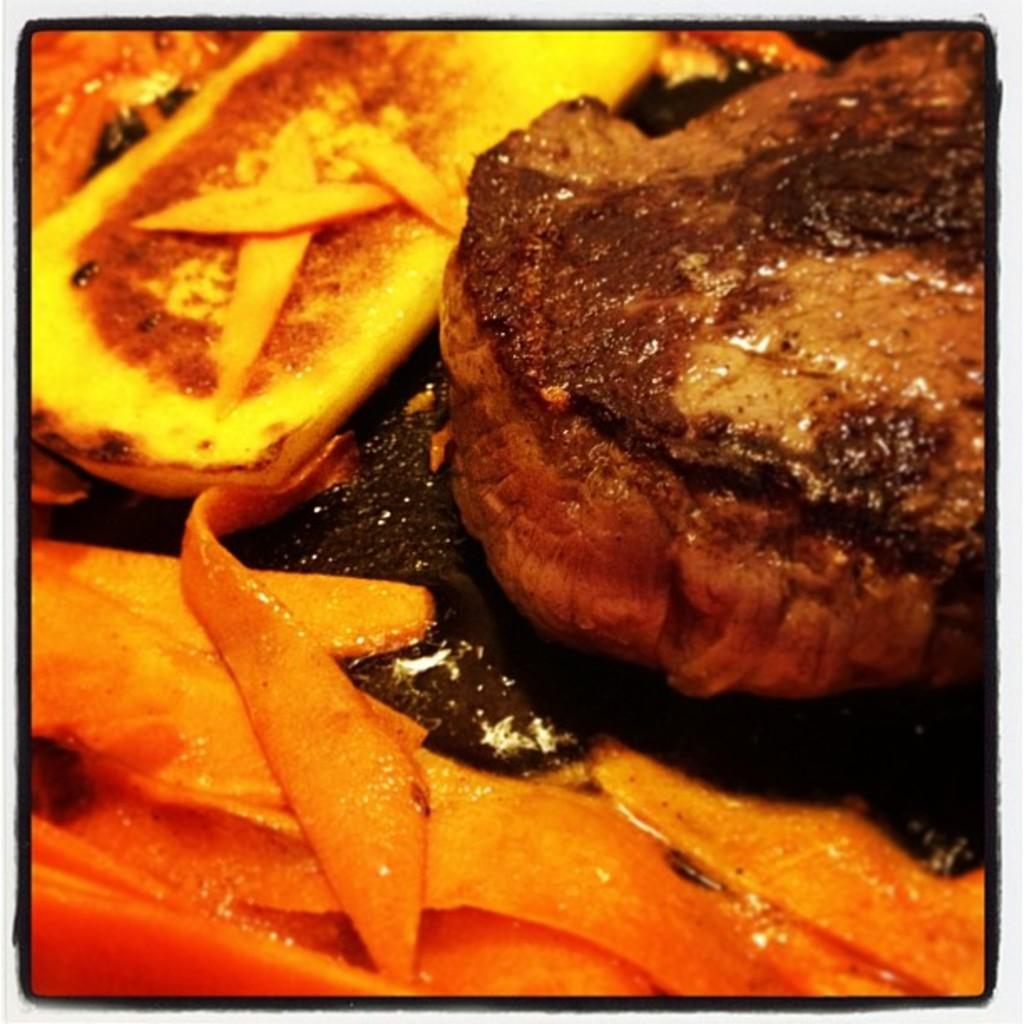What can be seen in the image related to food? There is some food in the image. What type of thread is being used to sew the advice onto the crib in the image? There is no thread, advice, or crib present in the image; it only contains food. 